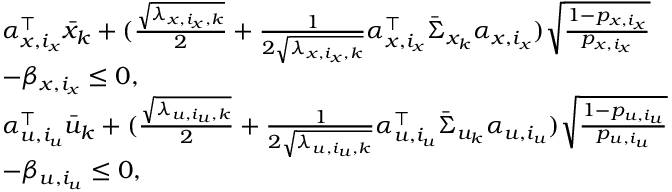<formula> <loc_0><loc_0><loc_500><loc_500>\begin{array} { r l } & { \alpha _ { x , i _ { x } } ^ { \top } \bar { x } _ { k } + ( \frac { \sqrt { \lambda _ { x , i _ { x } , k } } } { 2 } + \frac { 1 } { 2 \sqrt { \lambda _ { x , i _ { x } , k } } } \alpha _ { x , i _ { x } } ^ { \top } \bar { \Sigma } _ { x _ { k } } \alpha _ { x , i _ { x } } ) \sqrt { \frac { 1 - p _ { x , i _ { x } } } { p _ { x , i _ { x } } } } } \\ & { - \beta _ { x , i _ { x } } \leq 0 , } \\ & { \alpha _ { u , i _ { u } } ^ { \top } \bar { u } _ { k } + ( \frac { \sqrt { \lambda _ { u , i _ { u } , k } } } { 2 } + \frac { 1 } { 2 \sqrt { \lambda _ { u , i _ { u } , k } } } \alpha _ { u , i _ { u } } ^ { \top } \bar { \Sigma } _ { u _ { k } } \alpha _ { u , i _ { u } } ) \sqrt { \frac { 1 - p _ { u , i _ { u } } } { p _ { u , i _ { u } } } } } \\ & { - \beta _ { u , i _ { u } } \leq 0 , } \end{array}</formula> 